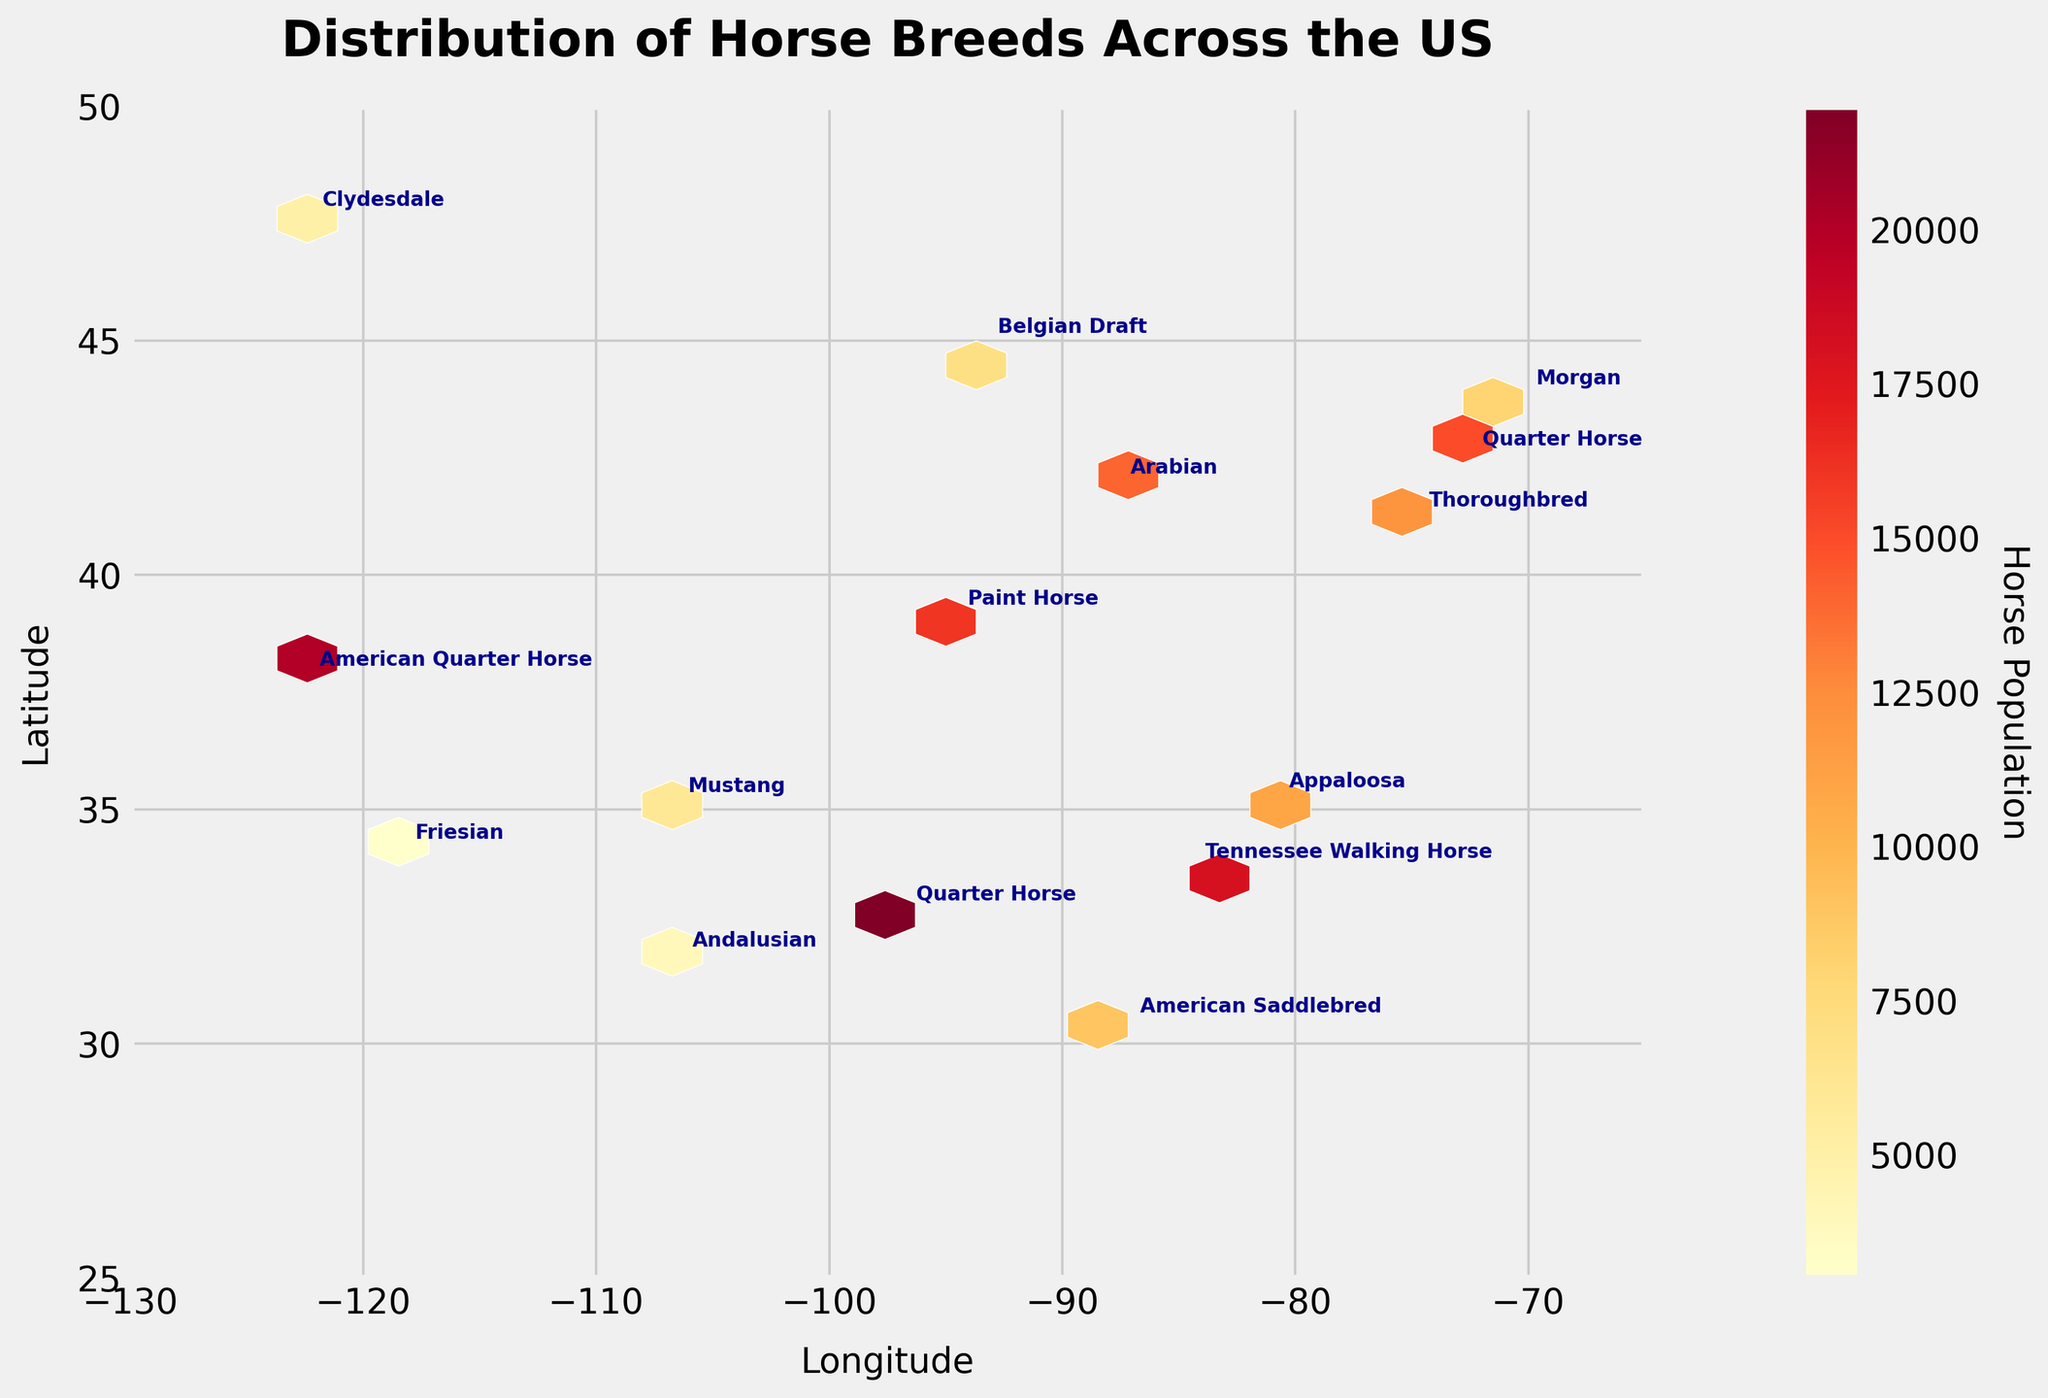What is the title of the figure? The title is displayed prominently at the top of the figure. It states the main subject of the plot.
Answer: Distribution of Horse Breeds Across the US What information is shown on the x-axis and y-axis? The x-axis represents longitude, and the y-axis represents latitude, which together determine the geographic locations in the US.
Answer: Longitude and Latitude Which region in the US has the highest density of horse population according to the hexbin plot color scale? The hexbin plot uses color intensity to indicate population density. The region with the brightest color, specifically in the Southwest, indicates the highest density.
Answer: Southwest Which breed of horse is most populous in the Southwest region? The annotation on the hexbin plot in the Southwest region shows the specific breeds. The Quarter Horse has the highest population in that region.
Answer: Quarter Horse How many distinct breeds are annotated in the figure? The figure includes annotations for different breeds at various geographic coordinates. Counting these gives the total number of breeds.
Answer: Eleven breeds What is the range of the color bar representing horse populations? The color bar on the right side of the hexbin plot visually represents the range of horse populations corresponding to color intensity.
Answer: From 3000 to 22000 What state in the Midwest is represented by the coordinate (-87.6, 41.9)? By referring to the latitude and longitude coordinates corresponding to the Midwest region, the given coordinates point to Chicago, Illinois.
Answer: Illinois Which breed has the smallest population and where is it located? The smallest population corresponds to the lowest value on the color scale, annotated at the specific coordinate in the Southwest region.
Answer: Andalusian, Southwest Is the data for the Northeast region more concentrated or dispersed compared to the other regions? By observing the concentration and spread of data points in the hexbin plot, one can see the density of color and annotations for each region. The Northeast shows more dispersion than the Southwest, but less than the Midwest and West.
Answer: More dispersed What is the total population of horse breeds in the Southeast region? Summing up the populations for Southeast breeds includes Tennessee Walking Horse (18000), American Saddlebred (9000), Appaloosa (11000).
Answer: 37000 Which region has the highest variety of horse breeds? Counting the distinct breeds annotated in each region helps identify the region with the most variety.
Answer: Southeast 